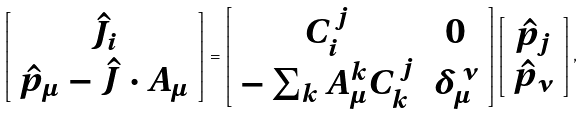<formula> <loc_0><loc_0><loc_500><loc_500>\left [ \begin{array} { c } \hat { J } _ { i } \\ \hat { p } _ { \mu } - { \hat { J } } \cdot { A } _ { \mu } \end{array} \right ] = \left [ \begin{array} { c c } C _ { i } ^ { \, j } & 0 \\ - \sum _ { k } A ^ { k } _ { \mu } C _ { k } ^ { \, j } & \delta _ { \mu } ^ { \, \nu } \end{array} \right ] \left [ \begin{array} { c } \hat { p } _ { j } \\ \hat { p } _ { \nu } \end{array} \right ] ,</formula> 